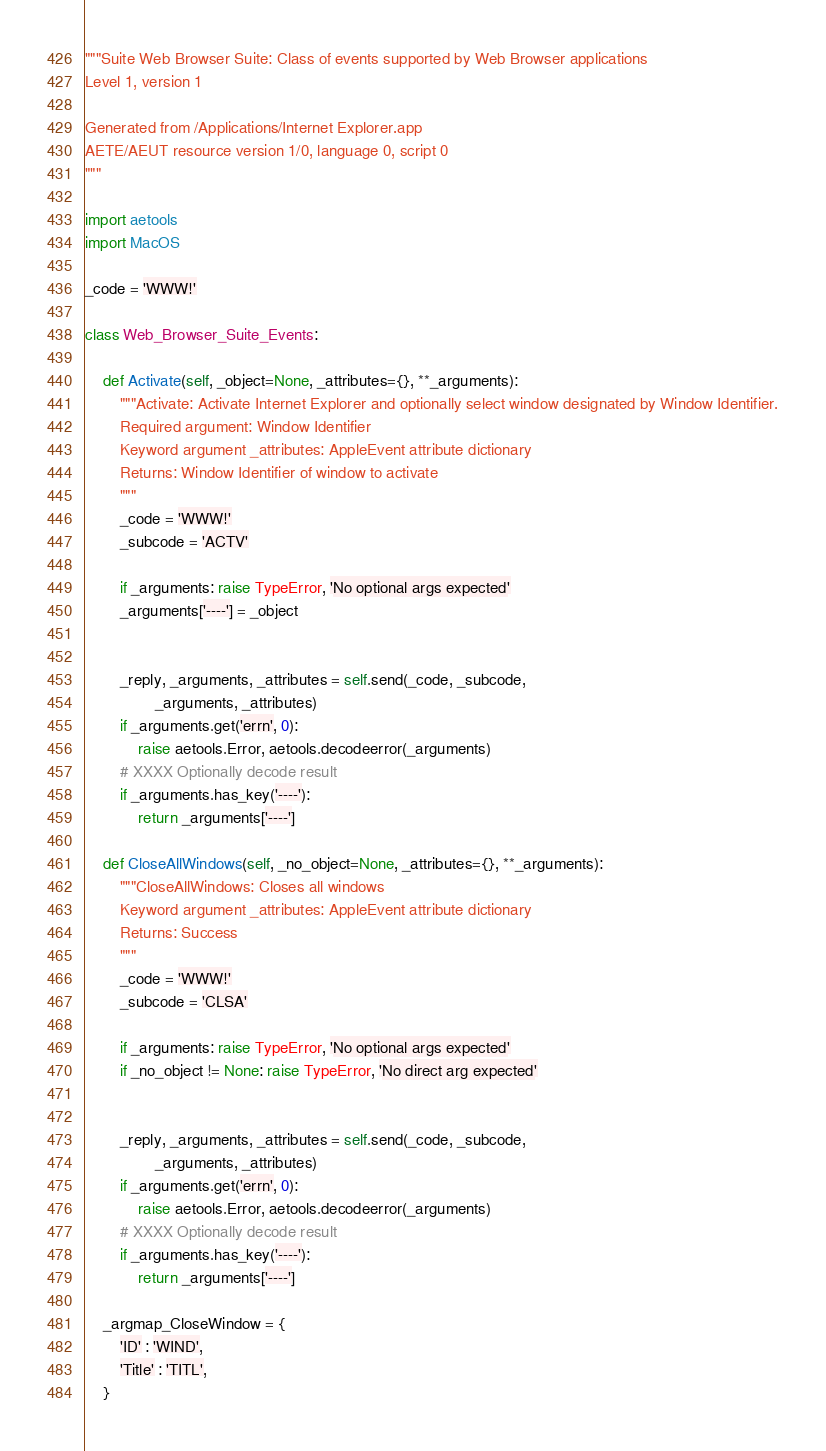<code> <loc_0><loc_0><loc_500><loc_500><_Python_>"""Suite Web Browser Suite: Class of events supported by Web Browser applications
Level 1, version 1

Generated from /Applications/Internet Explorer.app
AETE/AEUT resource version 1/0, language 0, script 0
"""

import aetools
import MacOS

_code = 'WWW!'

class Web_Browser_Suite_Events:

    def Activate(self, _object=None, _attributes={}, **_arguments):
        """Activate: Activate Internet Explorer and optionally select window designated by Window Identifier.
        Required argument: Window Identifier
        Keyword argument _attributes: AppleEvent attribute dictionary
        Returns: Window Identifier of window to activate
        """
        _code = 'WWW!'
        _subcode = 'ACTV'

        if _arguments: raise TypeError, 'No optional args expected'
        _arguments['----'] = _object


        _reply, _arguments, _attributes = self.send(_code, _subcode,
                _arguments, _attributes)
        if _arguments.get('errn', 0):
            raise aetools.Error, aetools.decodeerror(_arguments)
        # XXXX Optionally decode result
        if _arguments.has_key('----'):
            return _arguments['----']

    def CloseAllWindows(self, _no_object=None, _attributes={}, **_arguments):
        """CloseAllWindows: Closes all windows
        Keyword argument _attributes: AppleEvent attribute dictionary
        Returns: Success
        """
        _code = 'WWW!'
        _subcode = 'CLSA'

        if _arguments: raise TypeError, 'No optional args expected'
        if _no_object != None: raise TypeError, 'No direct arg expected'


        _reply, _arguments, _attributes = self.send(_code, _subcode,
                _arguments, _attributes)
        if _arguments.get('errn', 0):
            raise aetools.Error, aetools.decodeerror(_arguments)
        # XXXX Optionally decode result
        if _arguments.has_key('----'):
            return _arguments['----']

    _argmap_CloseWindow = {
        'ID' : 'WIND',
        'Title' : 'TITL',
    }
</code> 